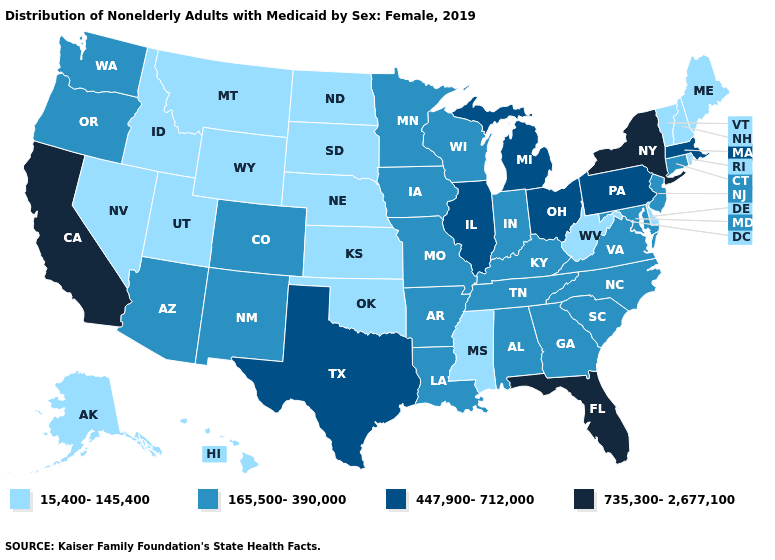Does the map have missing data?
Give a very brief answer. No. What is the highest value in the USA?
Short answer required. 735,300-2,677,100. What is the highest value in states that border New Mexico?
Short answer required. 447,900-712,000. Name the states that have a value in the range 735,300-2,677,100?
Write a very short answer. California, Florida, New York. Name the states that have a value in the range 735,300-2,677,100?
Give a very brief answer. California, Florida, New York. Name the states that have a value in the range 165,500-390,000?
Answer briefly. Alabama, Arizona, Arkansas, Colorado, Connecticut, Georgia, Indiana, Iowa, Kentucky, Louisiana, Maryland, Minnesota, Missouri, New Jersey, New Mexico, North Carolina, Oregon, South Carolina, Tennessee, Virginia, Washington, Wisconsin. Does the first symbol in the legend represent the smallest category?
Short answer required. Yes. Name the states that have a value in the range 735,300-2,677,100?
Quick response, please. California, Florida, New York. What is the lowest value in the USA?
Short answer required. 15,400-145,400. Name the states that have a value in the range 447,900-712,000?
Short answer required. Illinois, Massachusetts, Michigan, Ohio, Pennsylvania, Texas. Name the states that have a value in the range 735,300-2,677,100?
Answer briefly. California, Florida, New York. What is the highest value in states that border Utah?
Write a very short answer. 165,500-390,000. What is the highest value in the USA?
Answer briefly. 735,300-2,677,100. What is the value of Connecticut?
Give a very brief answer. 165,500-390,000. How many symbols are there in the legend?
Give a very brief answer. 4. 